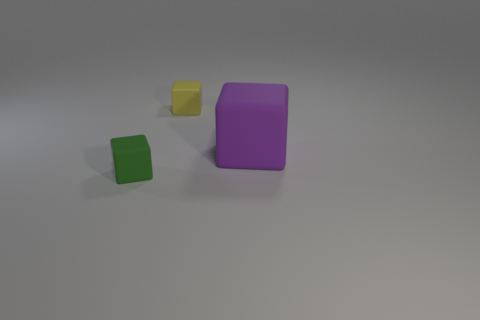Subtract all yellow cubes. How many cubes are left? 2 Add 2 small spheres. How many objects exist? 5 Subtract all green cubes. How many cubes are left? 2 Add 2 yellow cubes. How many yellow cubes are left? 3 Add 1 tiny yellow objects. How many tiny yellow objects exist? 2 Subtract 0 blue balls. How many objects are left? 3 Subtract all gray blocks. Subtract all green balls. How many blocks are left? 3 Subtract all big matte cubes. Subtract all matte cylinders. How many objects are left? 2 